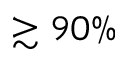<formula> <loc_0><loc_0><loc_500><loc_500>\gtrsim 9 0 \%</formula> 